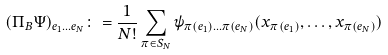Convert formula to latex. <formula><loc_0><loc_0><loc_500><loc_500>( \Pi _ { B } \Psi ) _ { e _ { 1 } \dots e _ { N } } \colon = \frac { 1 } { N ! } \sum _ { \pi \in S _ { N } } \psi _ { \pi ( e _ { 1 } ) \dots \pi ( e _ { N } ) } ( x _ { \pi ( e _ { 1 } ) } , \dots , x _ { \pi ( e _ { N } ) } )</formula> 